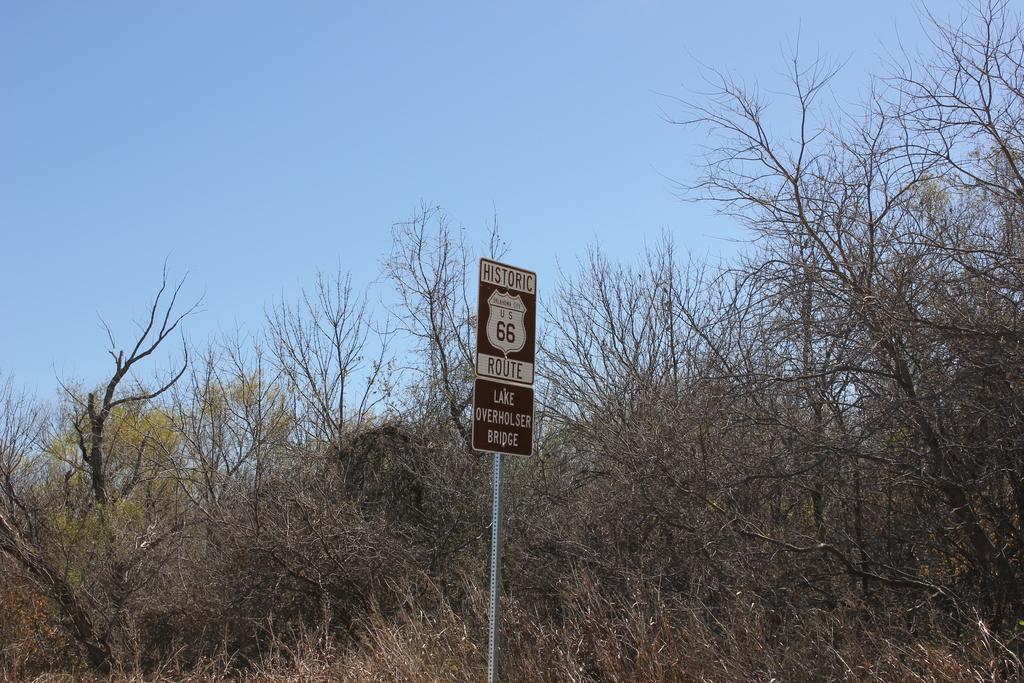How would you summarize this image in a sentence or two? In this image, we can see a sign board with pole. Background there are so many trees and sky. 